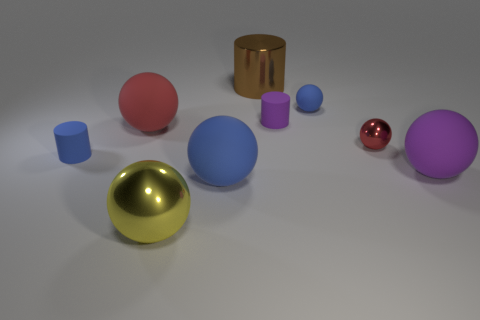How does the lighting affect the appearance of the objects? The image is lit in a way that generates soft shadows on the ground, lending a three-dimensional quality and depth to the objects. The metallic spheres, in particular, have pronounced highlights and reflections that enhance their shine and provide a sense of texture. 